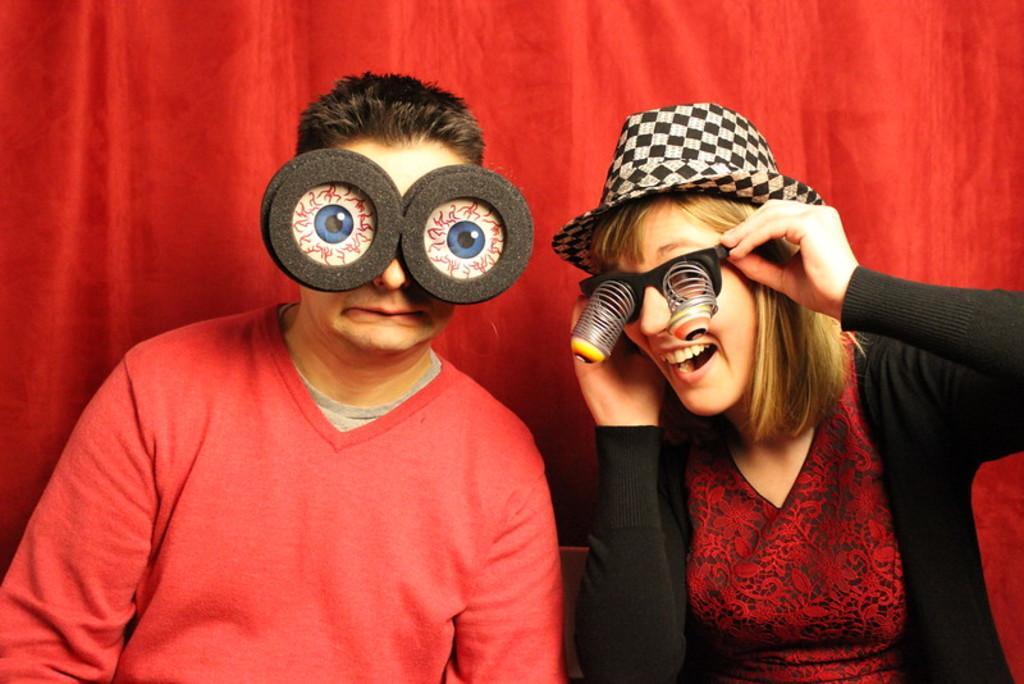In one or two sentences, can you explain what this image depicts? In this picture I can see a man and woman seated and I can see woman wore a cap on her head and I can see a curtain on the back and both of them were eyewear. 